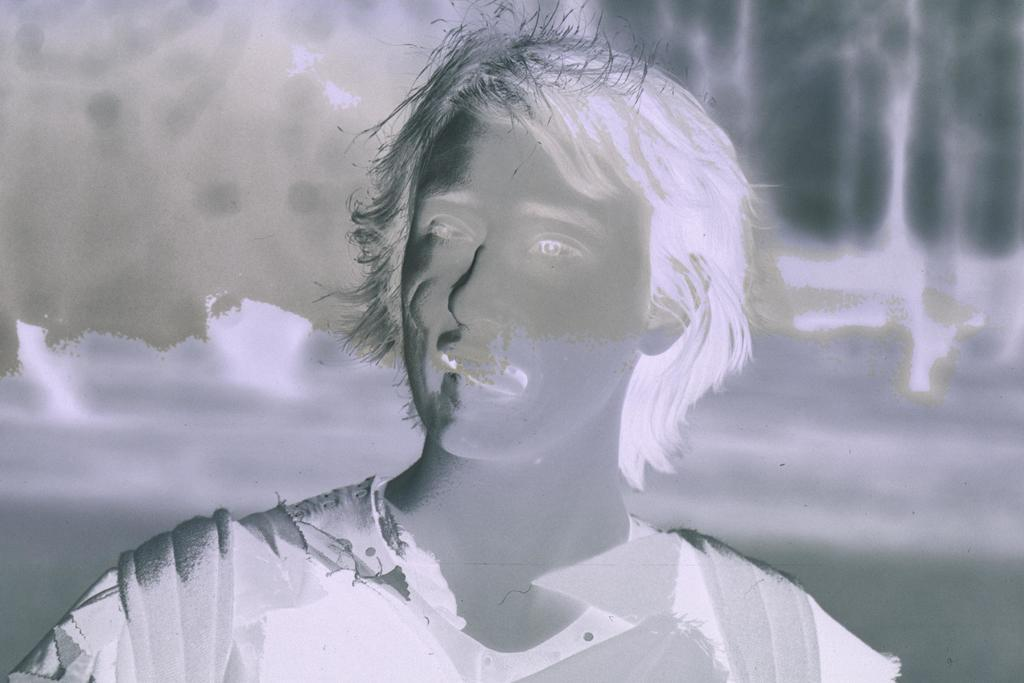What is the main subject of the image? There is a person in the image. What color scheme is used in the image? The image is black and white in color. Can you tell me how many rays are visible in the image? There are no rays present in the image, as it is black and white and does not depict any light sources. What type of thunder can be heard in the image? There is no sound in the image, so it is not possible to determine if any thunder is present. 